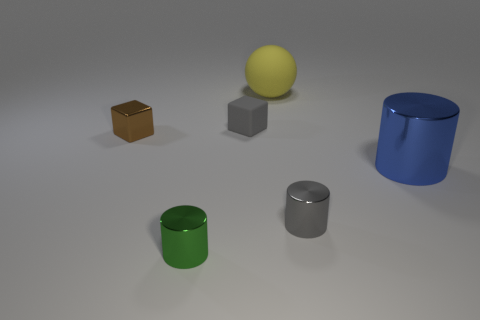Subtract all tiny gray cylinders. How many cylinders are left? 2 Add 3 large purple balls. How many objects exist? 9 Subtract all cubes. How many objects are left? 4 Subtract all small gray rubber spheres. Subtract all small gray shiny cylinders. How many objects are left? 5 Add 5 large metallic cylinders. How many large metallic cylinders are left? 6 Add 5 large red cylinders. How many large red cylinders exist? 5 Subtract 0 brown balls. How many objects are left? 6 Subtract all yellow cubes. Subtract all purple spheres. How many cubes are left? 2 